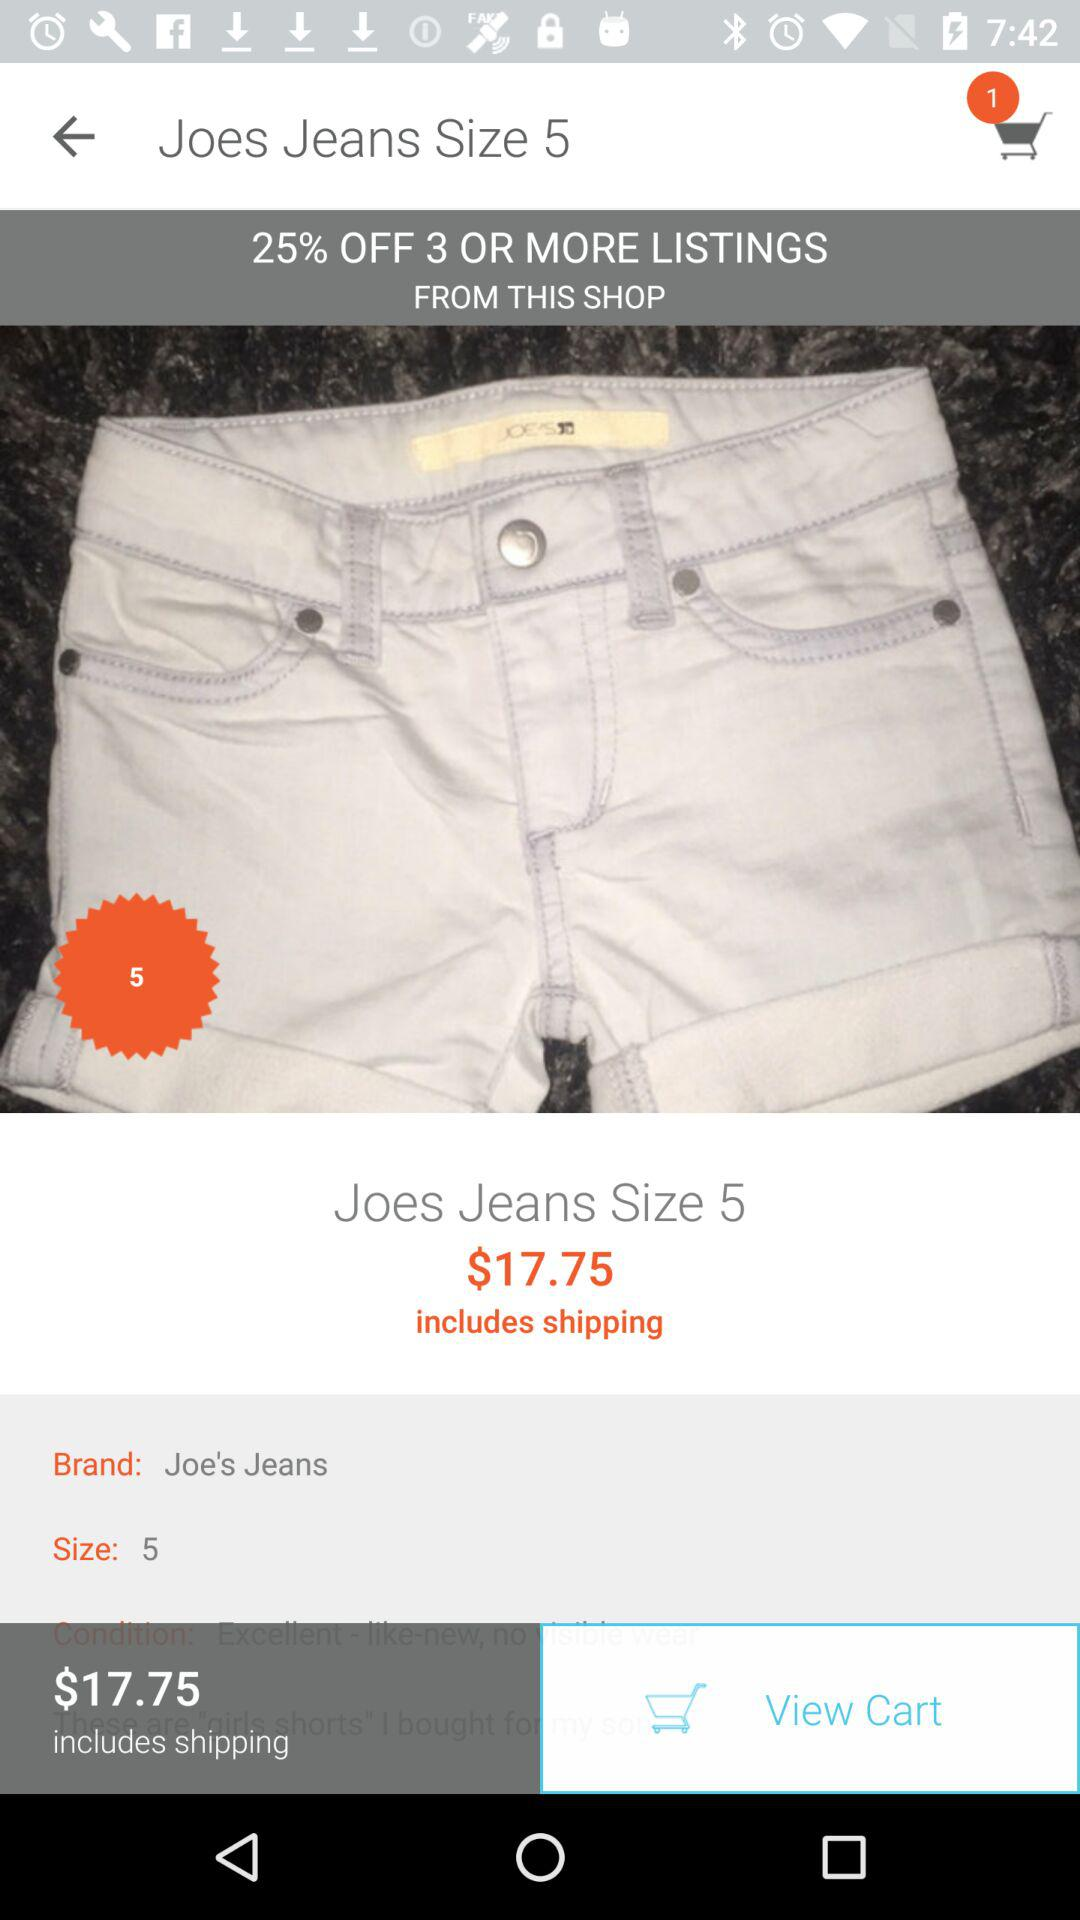What's the brand name? The brand name is "Joe's Jeans". 